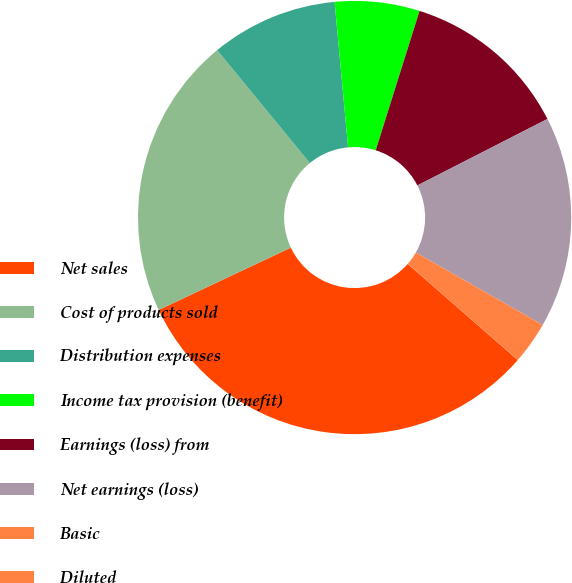Convert chart to OTSL. <chart><loc_0><loc_0><loc_500><loc_500><pie_chart><fcel>Net sales<fcel>Cost of products sold<fcel>Distribution expenses<fcel>Income tax provision (benefit)<fcel>Earnings (loss) from<fcel>Net earnings (loss)<fcel>Basic<fcel>Diluted<nl><fcel>31.56%<fcel>21.07%<fcel>9.47%<fcel>6.32%<fcel>12.63%<fcel>15.78%<fcel>3.16%<fcel>0.01%<nl></chart> 